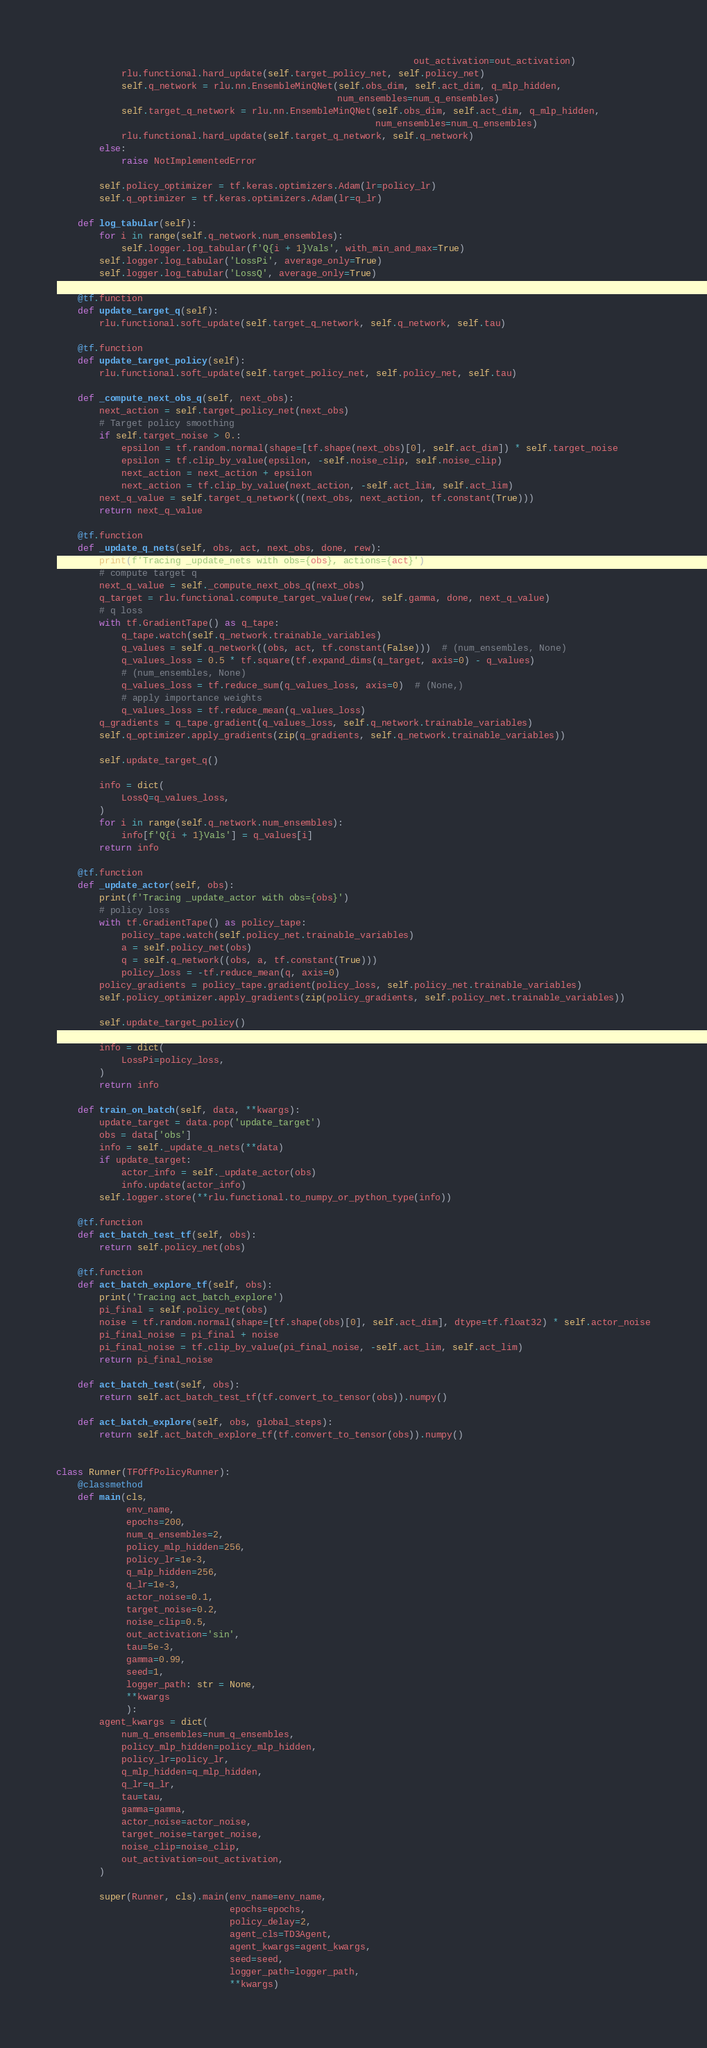<code> <loc_0><loc_0><loc_500><loc_500><_Python_>                                                                  out_activation=out_activation)
            rlu.functional.hard_update(self.target_policy_net, self.policy_net)
            self.q_network = rlu.nn.EnsembleMinQNet(self.obs_dim, self.act_dim, q_mlp_hidden,
                                                    num_ensembles=num_q_ensembles)
            self.target_q_network = rlu.nn.EnsembleMinQNet(self.obs_dim, self.act_dim, q_mlp_hidden,
                                                           num_ensembles=num_q_ensembles)
            rlu.functional.hard_update(self.target_q_network, self.q_network)
        else:
            raise NotImplementedError

        self.policy_optimizer = tf.keras.optimizers.Adam(lr=policy_lr)
        self.q_optimizer = tf.keras.optimizers.Adam(lr=q_lr)

    def log_tabular(self):
        for i in range(self.q_network.num_ensembles):
            self.logger.log_tabular(f'Q{i + 1}Vals', with_min_and_max=True)
        self.logger.log_tabular('LossPi', average_only=True)
        self.logger.log_tabular('LossQ', average_only=True)

    @tf.function
    def update_target_q(self):
        rlu.functional.soft_update(self.target_q_network, self.q_network, self.tau)

    @tf.function
    def update_target_policy(self):
        rlu.functional.soft_update(self.target_policy_net, self.policy_net, self.tau)

    def _compute_next_obs_q(self, next_obs):
        next_action = self.target_policy_net(next_obs)
        # Target policy smoothing
        if self.target_noise > 0.:
            epsilon = tf.random.normal(shape=[tf.shape(next_obs)[0], self.act_dim]) * self.target_noise
            epsilon = tf.clip_by_value(epsilon, -self.noise_clip, self.noise_clip)
            next_action = next_action + epsilon
            next_action = tf.clip_by_value(next_action, -self.act_lim, self.act_lim)
        next_q_value = self.target_q_network((next_obs, next_action, tf.constant(True)))
        return next_q_value

    @tf.function
    def _update_q_nets(self, obs, act, next_obs, done, rew):
        print(f'Tracing _update_nets with obs={obs}, actions={act}')
        # compute target q
        next_q_value = self._compute_next_obs_q(next_obs)
        q_target = rlu.functional.compute_target_value(rew, self.gamma, done, next_q_value)
        # q loss
        with tf.GradientTape() as q_tape:
            q_tape.watch(self.q_network.trainable_variables)
            q_values = self.q_network((obs, act, tf.constant(False)))  # (num_ensembles, None)
            q_values_loss = 0.5 * tf.square(tf.expand_dims(q_target, axis=0) - q_values)
            # (num_ensembles, None)
            q_values_loss = tf.reduce_sum(q_values_loss, axis=0)  # (None,)
            # apply importance weights
            q_values_loss = tf.reduce_mean(q_values_loss)
        q_gradients = q_tape.gradient(q_values_loss, self.q_network.trainable_variables)
        self.q_optimizer.apply_gradients(zip(q_gradients, self.q_network.trainable_variables))

        self.update_target_q()

        info = dict(
            LossQ=q_values_loss,
        )
        for i in range(self.q_network.num_ensembles):
            info[f'Q{i + 1}Vals'] = q_values[i]
        return info

    @tf.function
    def _update_actor(self, obs):
        print(f'Tracing _update_actor with obs={obs}')
        # policy loss
        with tf.GradientTape() as policy_tape:
            policy_tape.watch(self.policy_net.trainable_variables)
            a = self.policy_net(obs)
            q = self.q_network((obs, a, tf.constant(True)))
            policy_loss = -tf.reduce_mean(q, axis=0)
        policy_gradients = policy_tape.gradient(policy_loss, self.policy_net.trainable_variables)
        self.policy_optimizer.apply_gradients(zip(policy_gradients, self.policy_net.trainable_variables))

        self.update_target_policy()

        info = dict(
            LossPi=policy_loss,
        )
        return info

    def train_on_batch(self, data, **kwargs):
        update_target = data.pop('update_target')
        obs = data['obs']
        info = self._update_q_nets(**data)
        if update_target:
            actor_info = self._update_actor(obs)
            info.update(actor_info)
        self.logger.store(**rlu.functional.to_numpy_or_python_type(info))

    @tf.function
    def act_batch_test_tf(self, obs):
        return self.policy_net(obs)

    @tf.function
    def act_batch_explore_tf(self, obs):
        print('Tracing act_batch_explore')
        pi_final = self.policy_net(obs)
        noise = tf.random.normal(shape=[tf.shape(obs)[0], self.act_dim], dtype=tf.float32) * self.actor_noise
        pi_final_noise = pi_final + noise
        pi_final_noise = tf.clip_by_value(pi_final_noise, -self.act_lim, self.act_lim)
        return pi_final_noise

    def act_batch_test(self, obs):
        return self.act_batch_test_tf(tf.convert_to_tensor(obs)).numpy()

    def act_batch_explore(self, obs, global_steps):
        return self.act_batch_explore_tf(tf.convert_to_tensor(obs)).numpy()


class Runner(TFOffPolicyRunner):
    @classmethod
    def main(cls,
             env_name,
             epochs=200,
             num_q_ensembles=2,
             policy_mlp_hidden=256,
             policy_lr=1e-3,
             q_mlp_hidden=256,
             q_lr=1e-3,
             actor_noise=0.1,
             target_noise=0.2,
             noise_clip=0.5,
             out_activation='sin',
             tau=5e-3,
             gamma=0.99,
             seed=1,
             logger_path: str = None,
             **kwargs
             ):
        agent_kwargs = dict(
            num_q_ensembles=num_q_ensembles,
            policy_mlp_hidden=policy_mlp_hidden,
            policy_lr=policy_lr,
            q_mlp_hidden=q_mlp_hidden,
            q_lr=q_lr,
            tau=tau,
            gamma=gamma,
            actor_noise=actor_noise,
            target_noise=target_noise,
            noise_clip=noise_clip,
            out_activation=out_activation,
        )

        super(Runner, cls).main(env_name=env_name,
                                epochs=epochs,
                                policy_delay=2,
                                agent_cls=TD3Agent,
                                agent_kwargs=agent_kwargs,
                                seed=seed,
                                logger_path=logger_path,
                                **kwargs)
</code> 